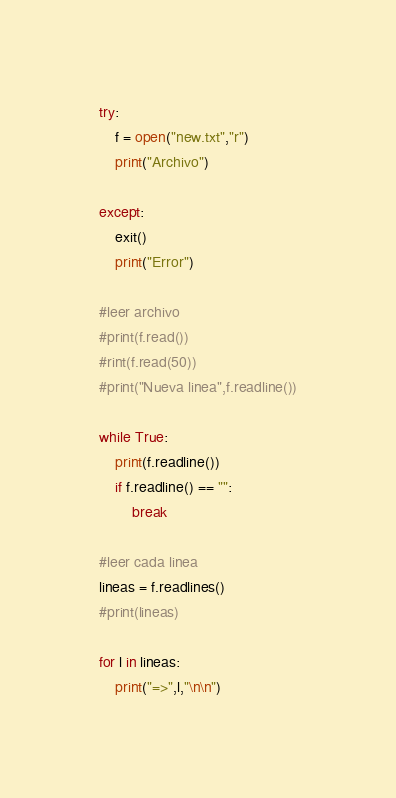Convert code to text. <code><loc_0><loc_0><loc_500><loc_500><_Python_>try:
    f = open("new.txt","r")
    print("Archivo")

except:
    exit()
    print("Error")

#leer archivo
#print(f.read())
#rint(f.read(50))
#print("Nueva linea",f.readline())

while True:
    print(f.readline())
    if f.readline() == "":
        break
    
#leer cada linea
lineas = f.readlines()
#print(lineas)

for l in lineas:
    print("=>",l,"\n\n")

</code> 